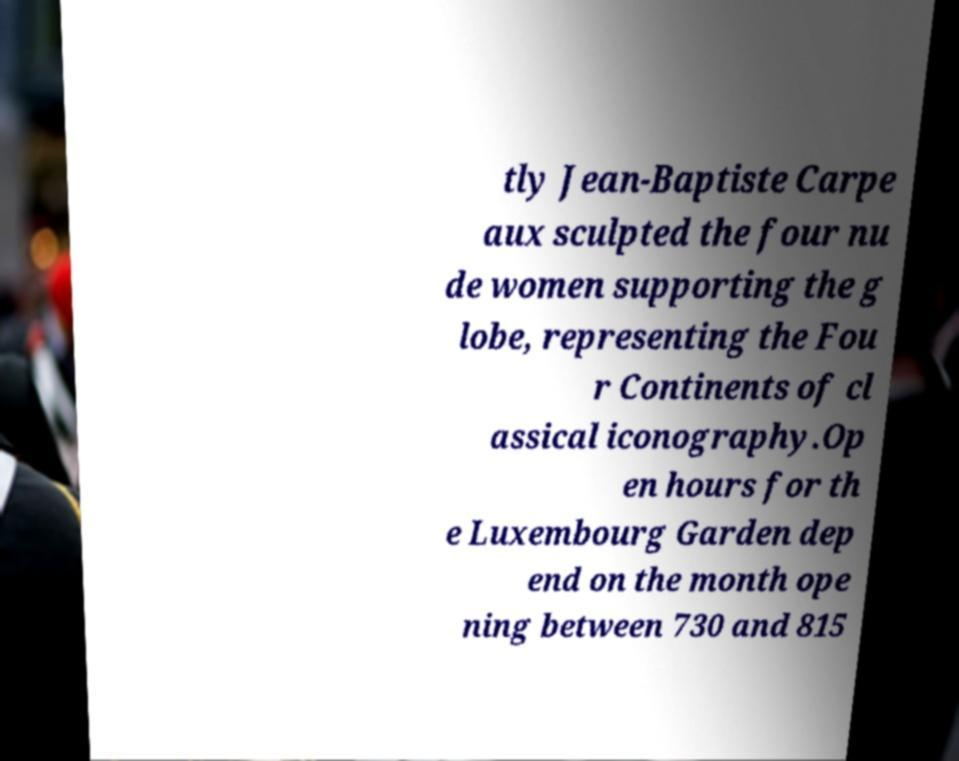There's text embedded in this image that I need extracted. Can you transcribe it verbatim? tly Jean-Baptiste Carpe aux sculpted the four nu de women supporting the g lobe, representing the Fou r Continents of cl assical iconography.Op en hours for th e Luxembourg Garden dep end on the month ope ning between 730 and 815 